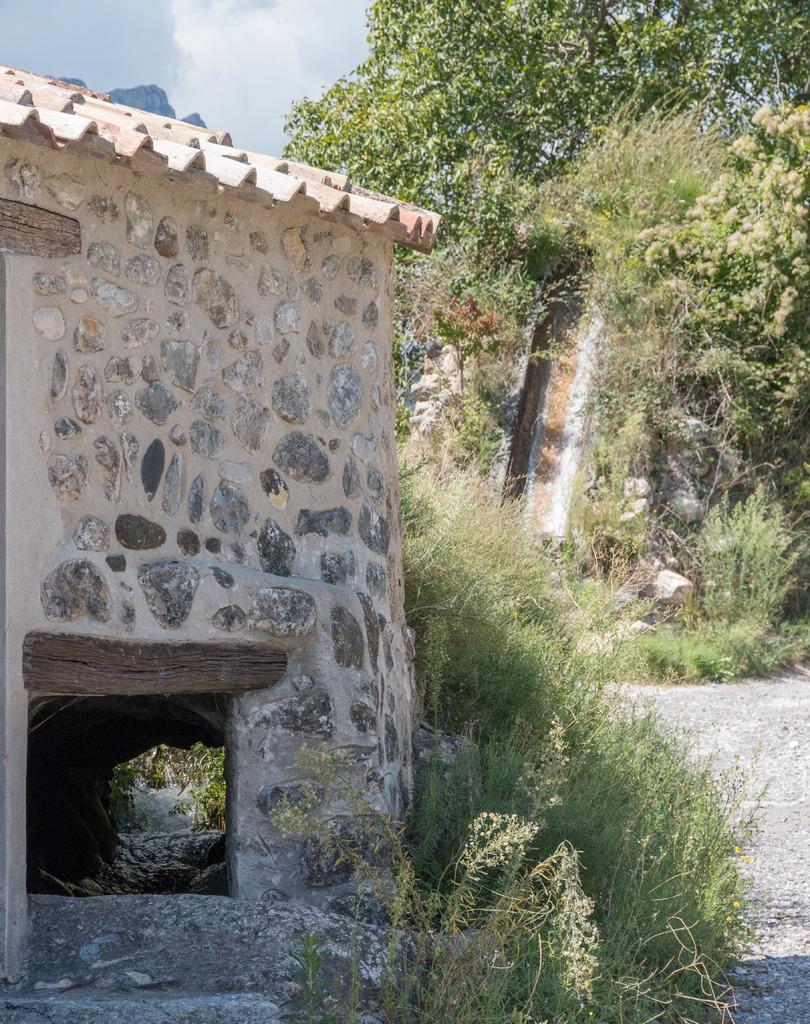In one or two sentences, can you explain what this image depicts? In this picture we can see a shed, plants on the ground, rocks, trees and in the background we can see the sky. 